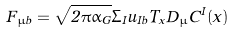Convert formula to latex. <formula><loc_0><loc_0><loc_500><loc_500>F _ { \mu \bar { b } } = \sqrt { 2 \pi \alpha _ { G } } \Sigma _ { I } u _ { I b } T _ { x } D _ { \mu } C ^ { I } ( x )</formula> 